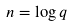<formula> <loc_0><loc_0><loc_500><loc_500>n = \log { q }</formula> 